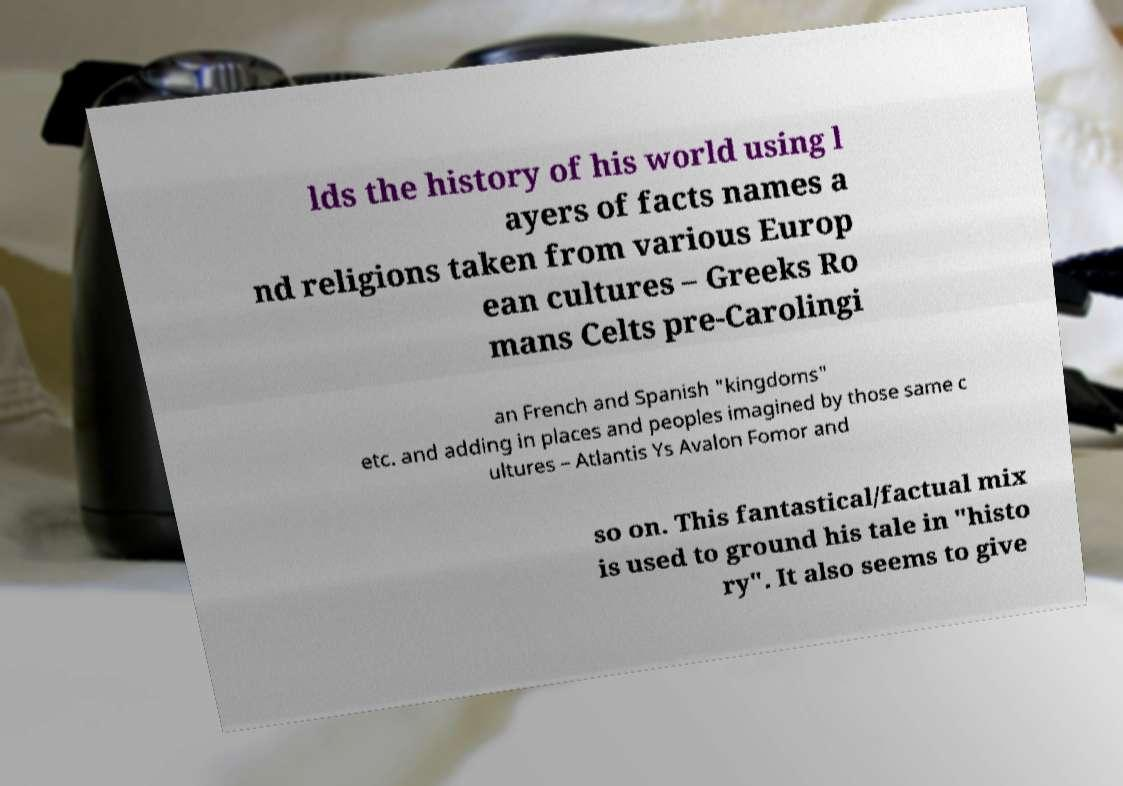I need the written content from this picture converted into text. Can you do that? lds the history of his world using l ayers of facts names a nd religions taken from various Europ ean cultures – Greeks Ro mans Celts pre-Carolingi an French and Spanish "kingdoms" etc. and adding in places and peoples imagined by those same c ultures – Atlantis Ys Avalon Fomor and so on. This fantastical/factual mix is used to ground his tale in "histo ry". It also seems to give 